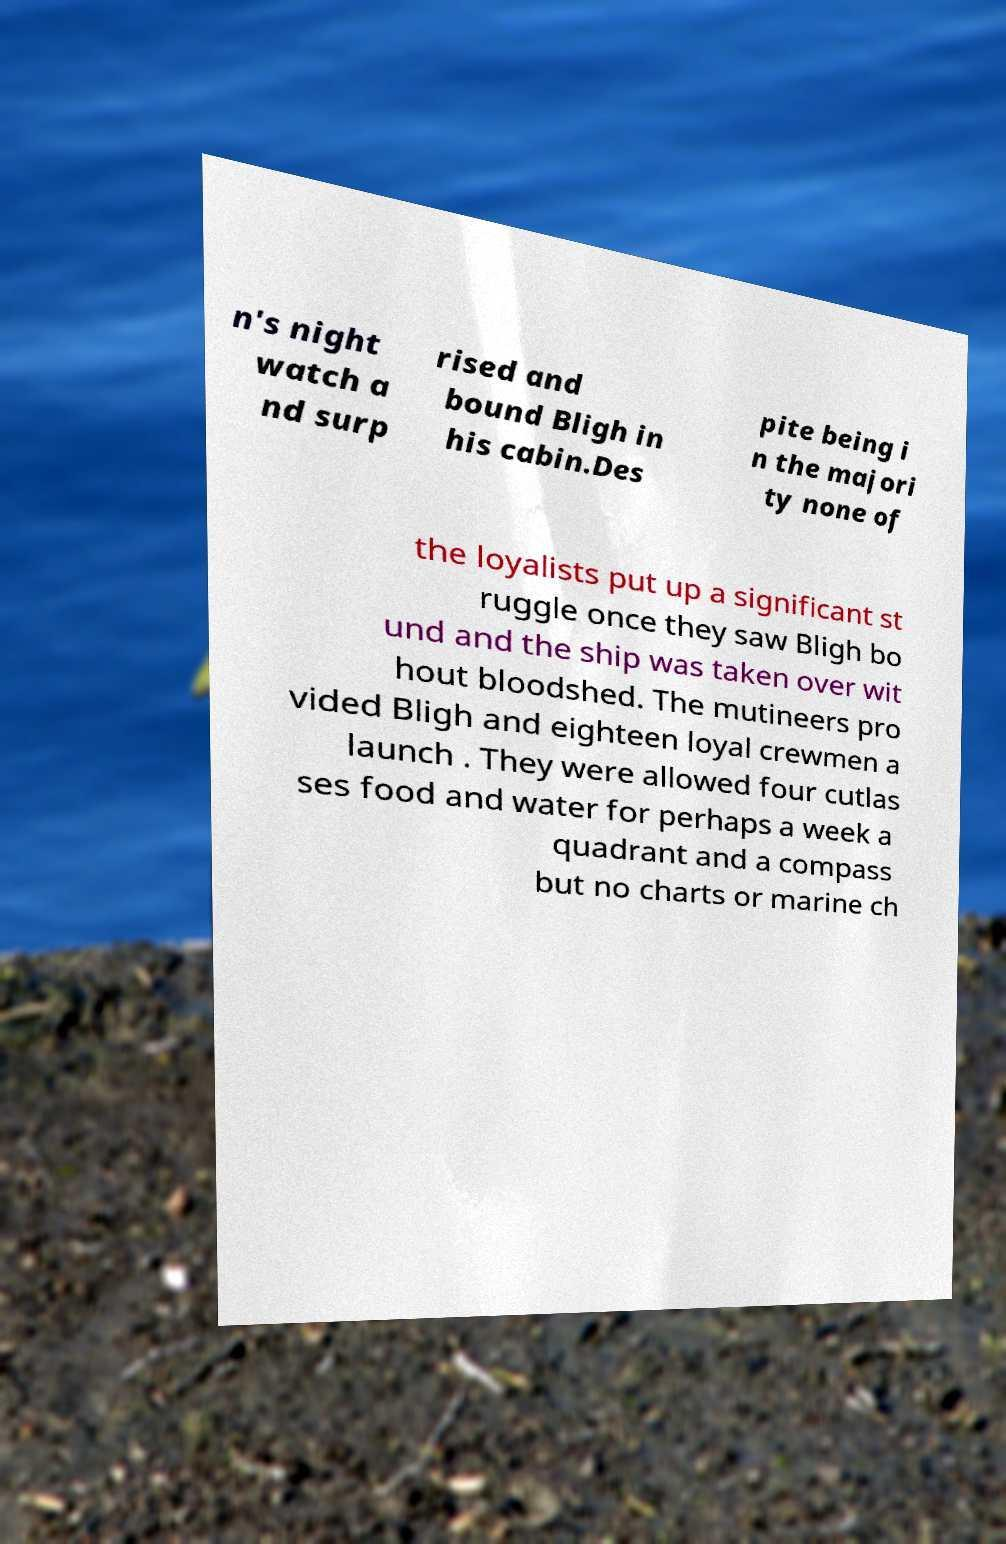Could you extract and type out the text from this image? n's night watch a nd surp rised and bound Bligh in his cabin.Des pite being i n the majori ty none of the loyalists put up a significant st ruggle once they saw Bligh bo und and the ship was taken over wit hout bloodshed. The mutineers pro vided Bligh and eighteen loyal crewmen a launch . They were allowed four cutlas ses food and water for perhaps a week a quadrant and a compass but no charts or marine ch 